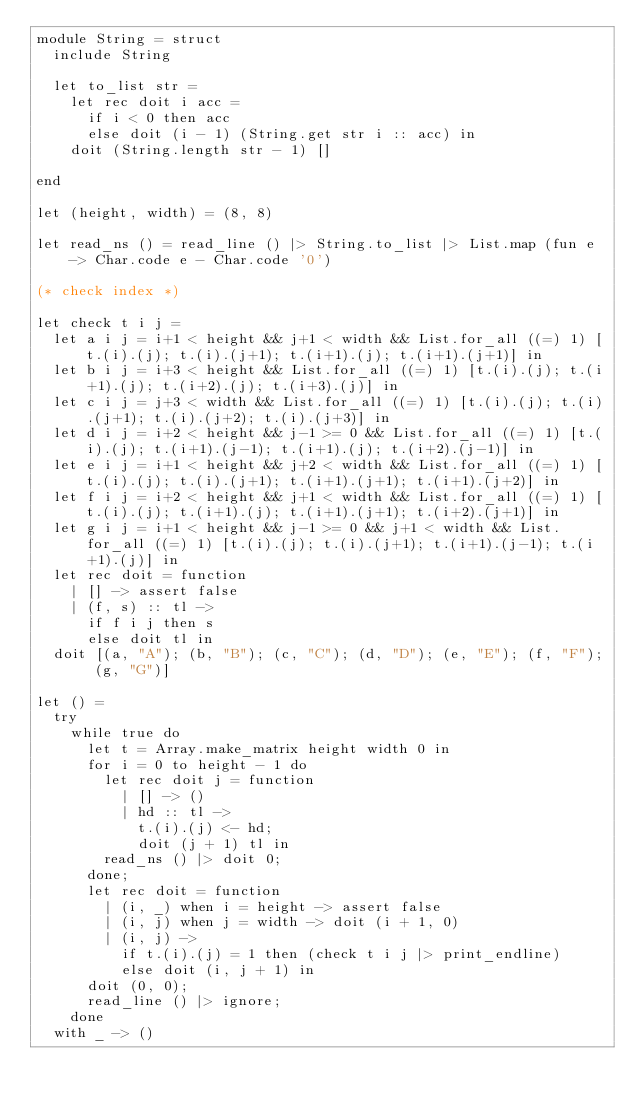<code> <loc_0><loc_0><loc_500><loc_500><_OCaml_>module String = struct
  include String

  let to_list str =
    let rec doit i acc =
      if i < 0 then acc
      else doit (i - 1) (String.get str i :: acc) in
    doit (String.length str - 1) []

end

let (height, width) = (8, 8)

let read_ns () = read_line () |> String.to_list |> List.map (fun e -> Char.code e - Char.code '0')

(* check index *)

let check t i j =
  let a i j = i+1 < height && j+1 < width && List.for_all ((=) 1) [t.(i).(j); t.(i).(j+1); t.(i+1).(j); t.(i+1).(j+1)] in
  let b i j = i+3 < height && List.for_all ((=) 1) [t.(i).(j); t.(i+1).(j); t.(i+2).(j); t.(i+3).(j)] in
  let c i j = j+3 < width && List.for_all ((=) 1) [t.(i).(j); t.(i).(j+1); t.(i).(j+2); t.(i).(j+3)] in
  let d i j = i+2 < height && j-1 >= 0 && List.for_all ((=) 1) [t.(i).(j); t.(i+1).(j-1); t.(i+1).(j); t.(i+2).(j-1)] in
  let e i j = i+1 < height && j+2 < width && List.for_all ((=) 1) [t.(i).(j); t.(i).(j+1); t.(i+1).(j+1); t.(i+1).(j+2)] in
  let f i j = i+2 < height && j+1 < width && List.for_all ((=) 1) [t.(i).(j); t.(i+1).(j); t.(i+1).(j+1); t.(i+2).(j+1)] in
  let g i j = i+1 < height && j-1 >= 0 && j+1 < width && List.for_all ((=) 1) [t.(i).(j); t.(i).(j+1); t.(i+1).(j-1); t.(i+1).(j)] in
  let rec doit = function
    | [] -> assert false
    | (f, s) :: tl ->
      if f i j then s
      else doit tl in
  doit [(a, "A"); (b, "B"); (c, "C"); (d, "D"); (e, "E"); (f, "F"); (g, "G")]

let () =
  try
    while true do
      let t = Array.make_matrix height width 0 in
      for i = 0 to height - 1 do
        let rec doit j = function
          | [] -> ()
          | hd :: tl ->
            t.(i).(j) <- hd;
            doit (j + 1) tl in
        read_ns () |> doit 0;
      done;
      let rec doit = function
        | (i, _) when i = height -> assert false
        | (i, j) when j = width -> doit (i + 1, 0)
        | (i, j) ->
          if t.(i).(j) = 1 then (check t i j |> print_endline)
          else doit (i, j + 1) in
      doit (0, 0);
      read_line () |> ignore;
    done
  with _ -> ()</code> 